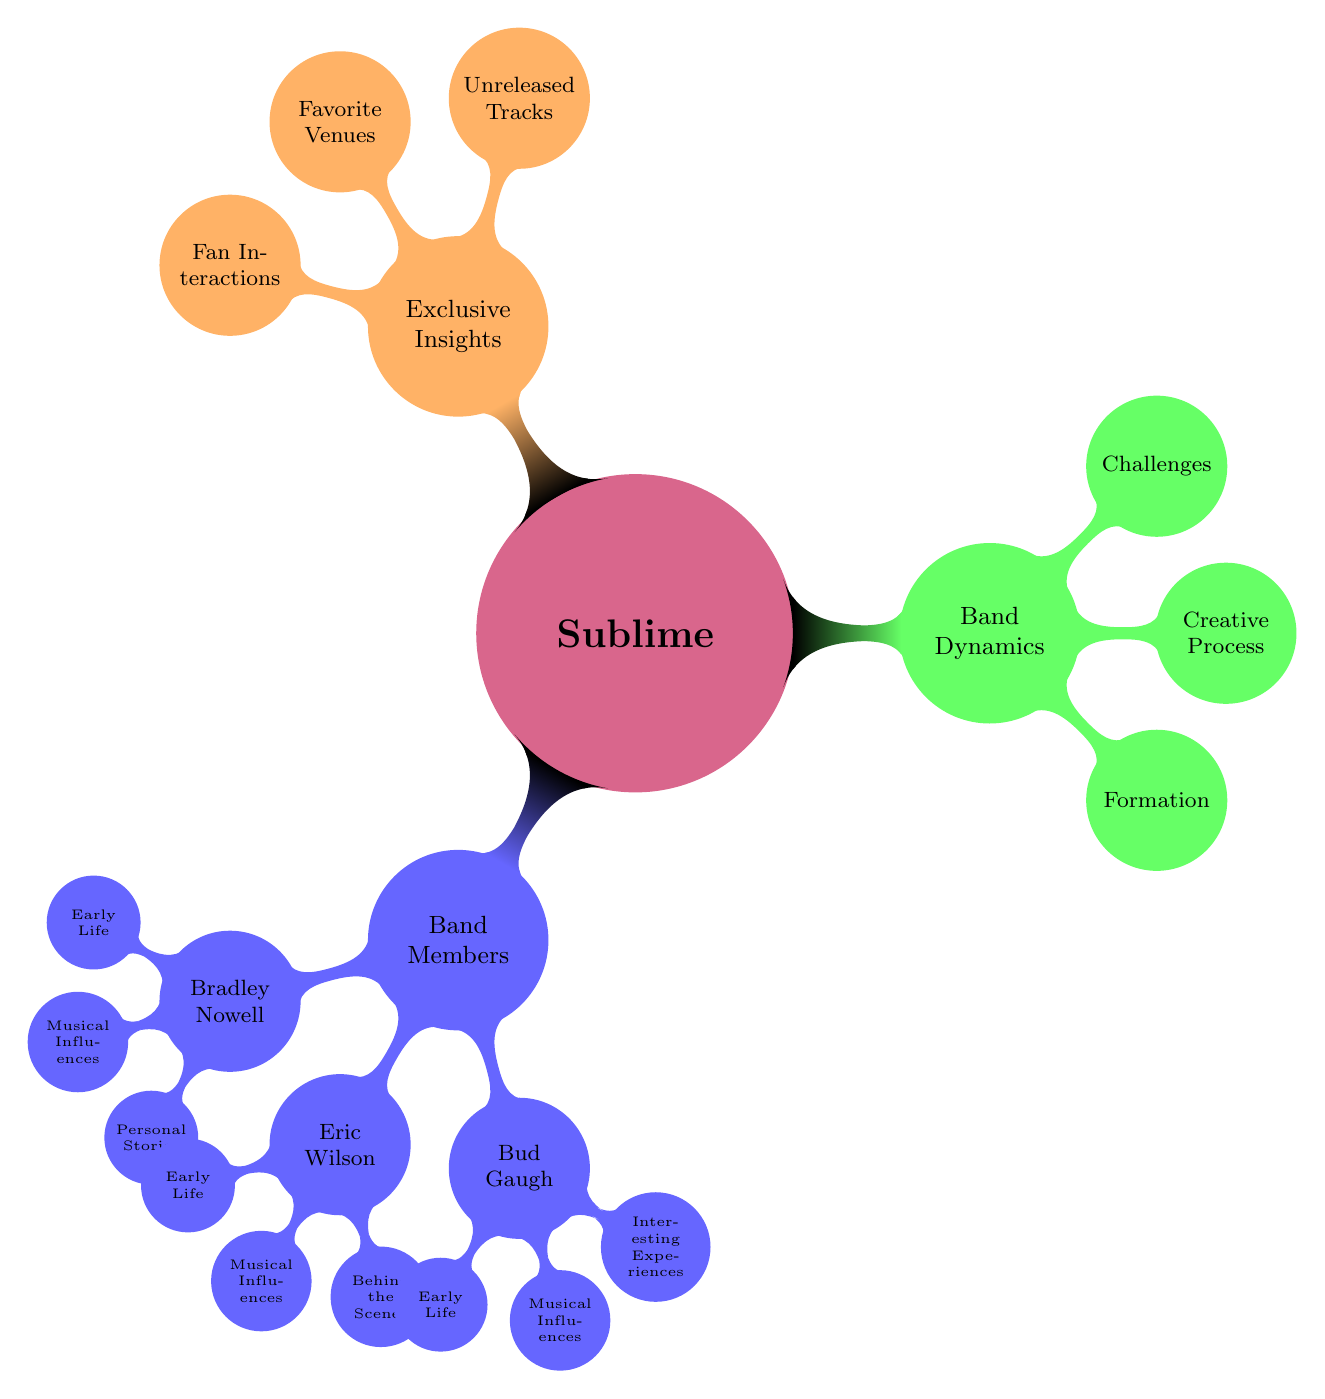What are the three band members mentioned in the diagram? The diagram specifically lists three band members under the "Band Members" branch: Bradley Nowell, Eric Wilson, and Bud Gaugh.
Answer: Bradley Nowell, Eric Wilson, Bud Gaugh How many nodes are there under "Band Members"? The "Band Members" branch has three subnodes: Bradley Nowell, Eric Wilson, and Bud Gaugh, which makes a total of three nodes.
Answer: 3 What unique category is included under "Exclusive Insights"? The "Exclusive Insights" branch contains three unique aspects: Unreleased Tracks, Favorite Venues, and Fan Interactions. Among these, "Unreleased Tracks" stands out as it refers to music not previously released.
Answer: Unreleased Tracks Which band member has a subnode about "Behind the Scenes"? The "Behind the Scenes" subnode is specifically associated with Eric Wilson in the diagram, highlighting his day-to-day life and interesting facts.
Answer: Eric Wilson What does the "Formation" node describe? The "Formation" node under "Band Dynamics" describes how the band met and started, outlining the beginnings of their journey together.
Answer: How the band met and started Which band member has a subnode about "Personal Stories"? Bradley Nowell is associated with the "Personal Stories" subnode in the diagram, which relates to anecdotes about his life on tour and personal experiences.
Answer: Bradley Nowell How does the diagram categorize challenges faced by the band? The diagram categorizes challenges under the "Band Dynamics" branch as a separate node, indicating the obstacles the band faced during their career and how they overcame them.
Answer: Challenges What are the three aspects listed under "Band Dynamics"? The three aspects listed under "Band Dynamics" are Formation, Creative Process, and Challenges, providing insights into how the band operated.
Answer: Formation, Creative Process, Challenges 